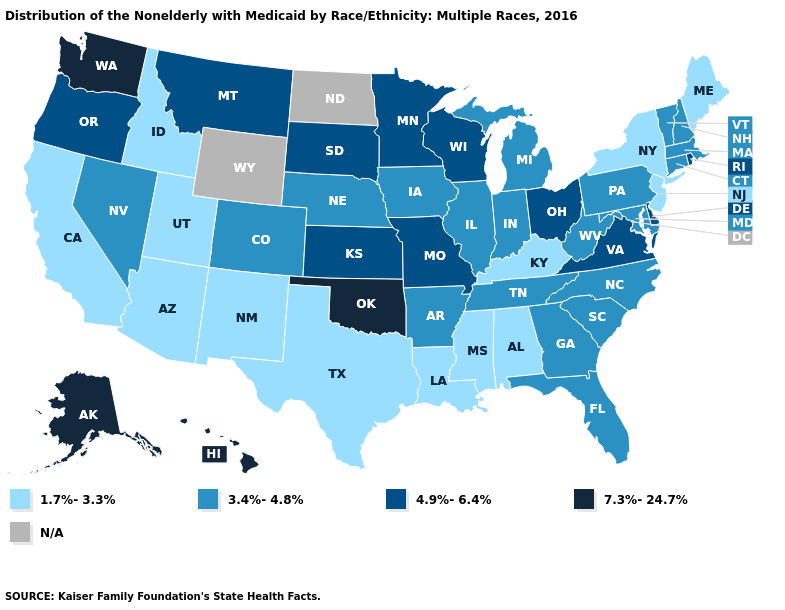What is the value of Louisiana?
Write a very short answer. 1.7%-3.3%. Name the states that have a value in the range 7.3%-24.7%?
Quick response, please. Alaska, Hawaii, Oklahoma, Washington. What is the value of Nebraska?
Short answer required. 3.4%-4.8%. Name the states that have a value in the range 4.9%-6.4%?
Give a very brief answer. Delaware, Kansas, Minnesota, Missouri, Montana, Ohio, Oregon, Rhode Island, South Dakota, Virginia, Wisconsin. What is the highest value in the West ?
Give a very brief answer. 7.3%-24.7%. Name the states that have a value in the range N/A?
Answer briefly. North Dakota, Wyoming. Does the first symbol in the legend represent the smallest category?
Keep it brief. Yes. Name the states that have a value in the range N/A?
Short answer required. North Dakota, Wyoming. What is the highest value in states that border Missouri?
Answer briefly. 7.3%-24.7%. What is the value of New Hampshire?
Concise answer only. 3.4%-4.8%. Name the states that have a value in the range 4.9%-6.4%?
Concise answer only. Delaware, Kansas, Minnesota, Missouri, Montana, Ohio, Oregon, Rhode Island, South Dakota, Virginia, Wisconsin. What is the value of Utah?
Quick response, please. 1.7%-3.3%. Does Ohio have the highest value in the USA?
Quick response, please. No. What is the value of Texas?
Answer briefly. 1.7%-3.3%. Name the states that have a value in the range 4.9%-6.4%?
Give a very brief answer. Delaware, Kansas, Minnesota, Missouri, Montana, Ohio, Oregon, Rhode Island, South Dakota, Virginia, Wisconsin. 